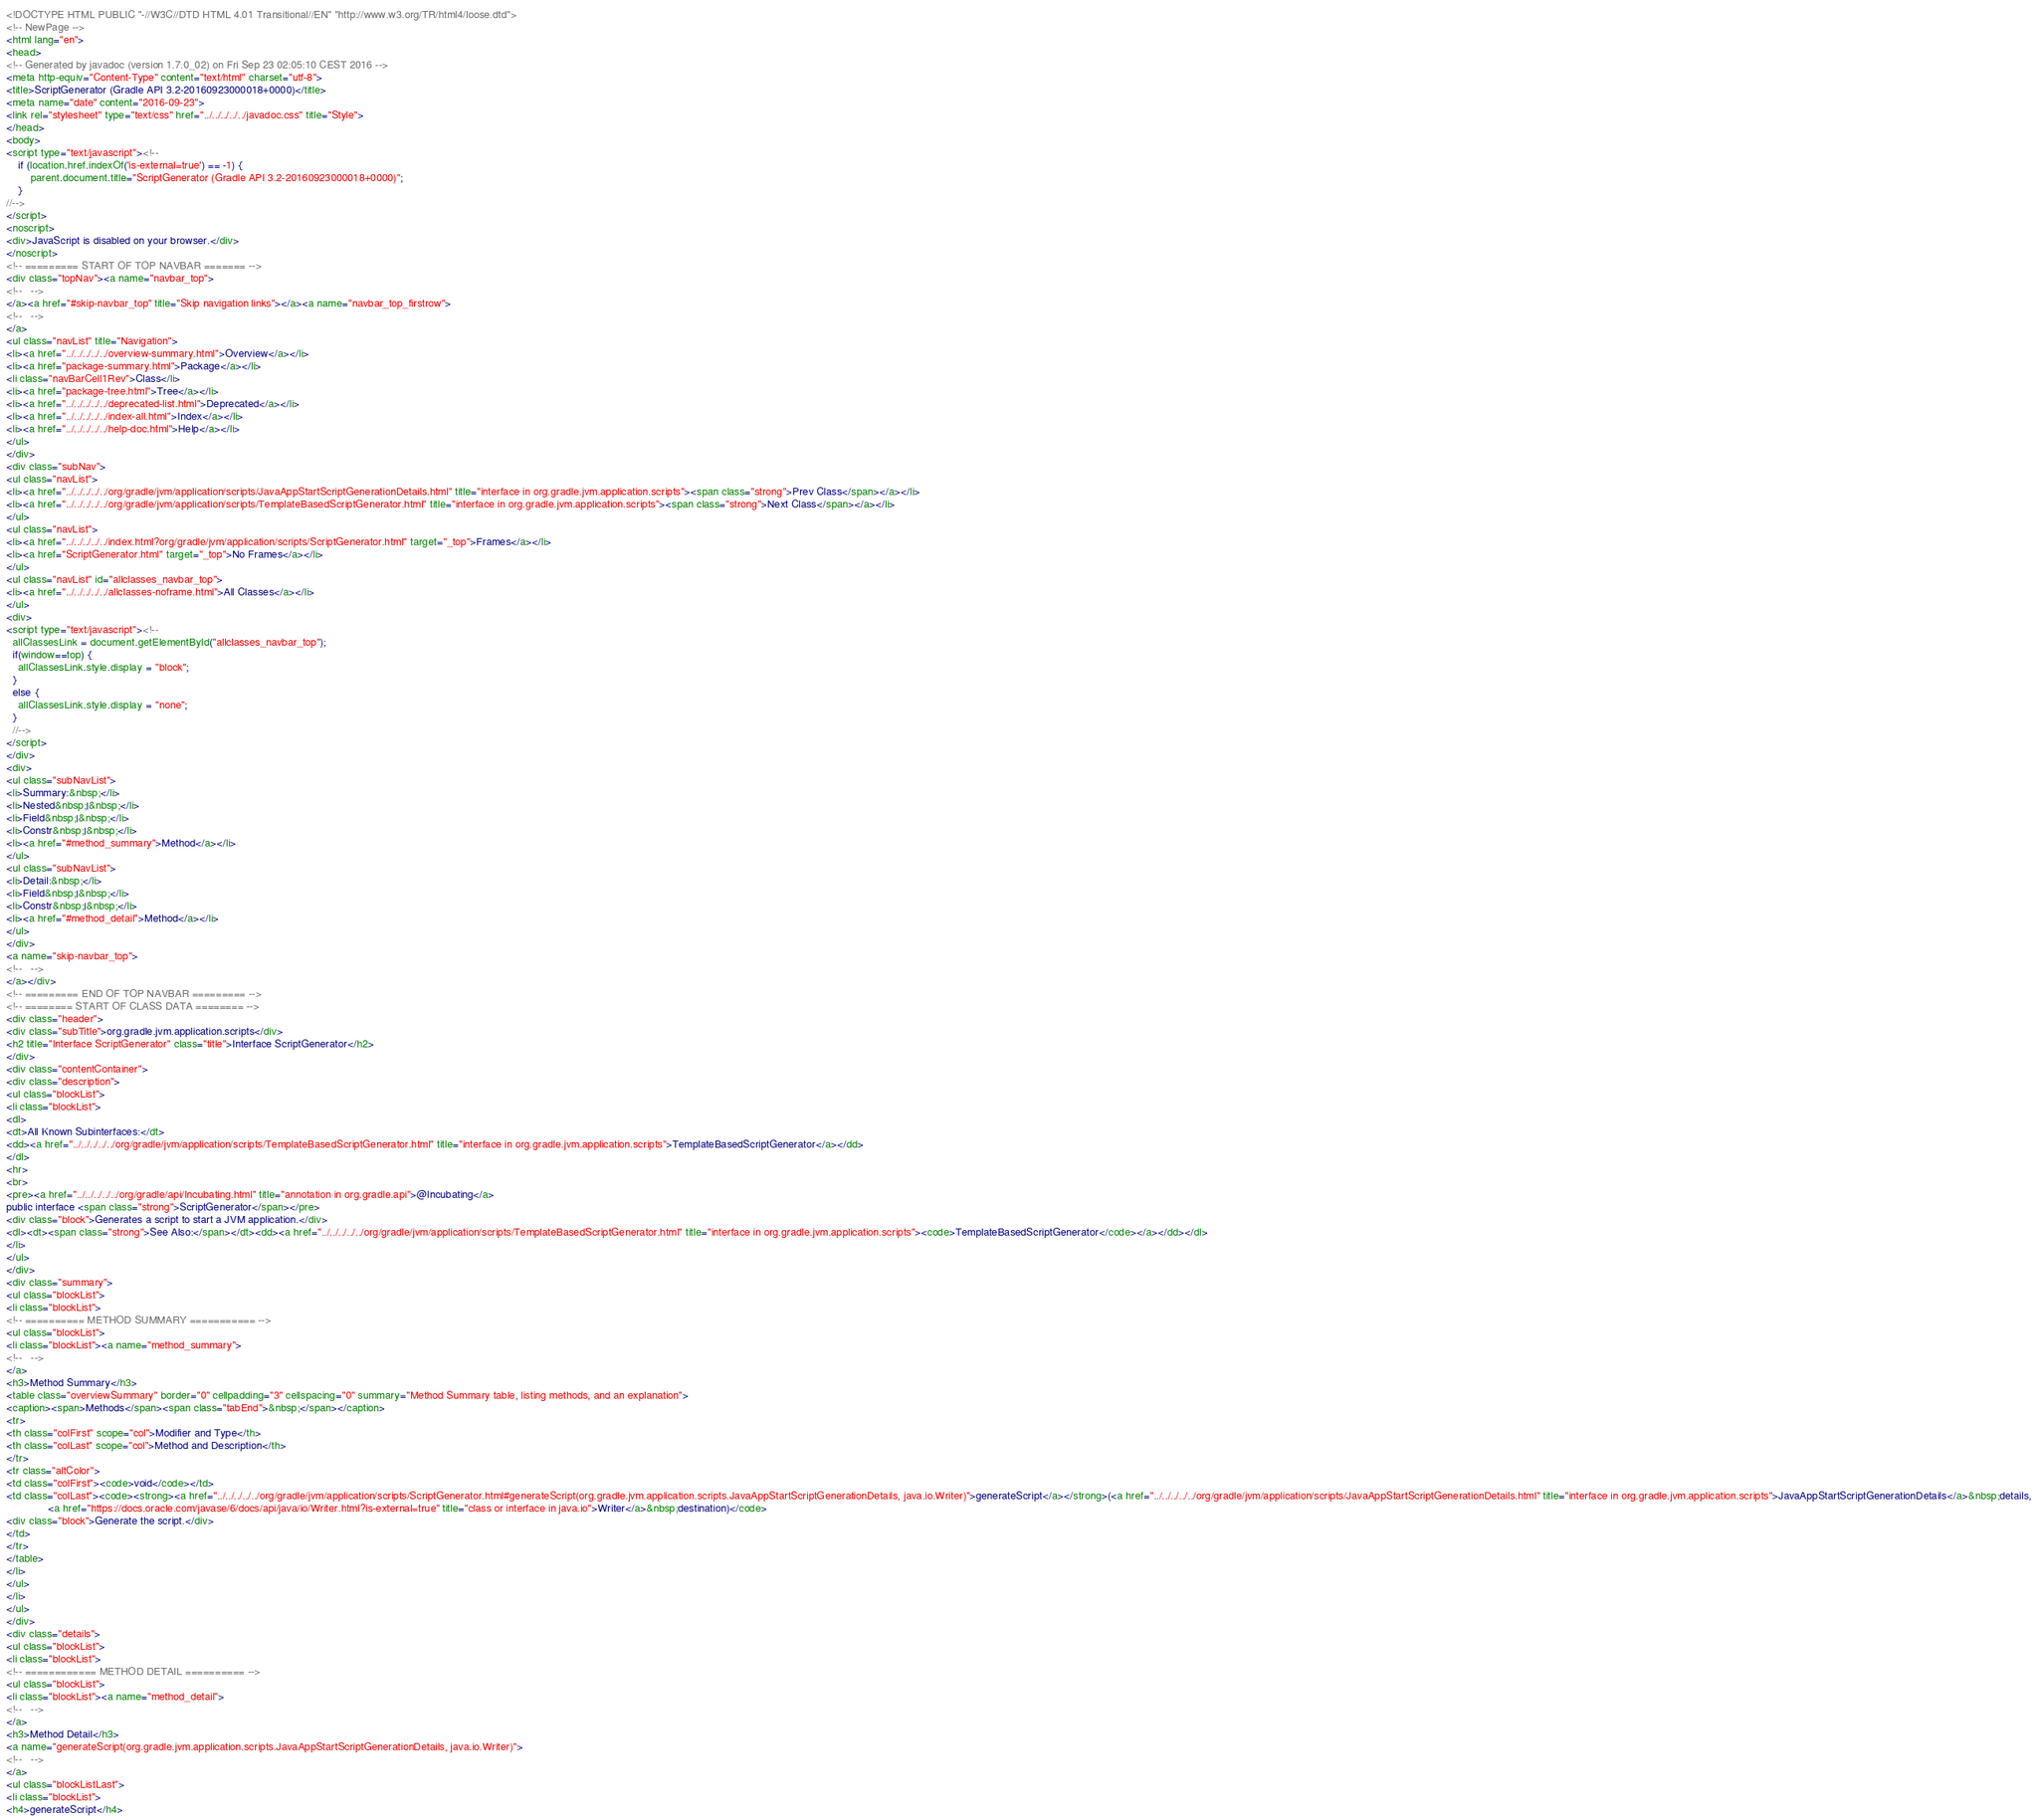<code> <loc_0><loc_0><loc_500><loc_500><_HTML_><!DOCTYPE HTML PUBLIC "-//W3C//DTD HTML 4.01 Transitional//EN" "http://www.w3.org/TR/html4/loose.dtd">
<!-- NewPage -->
<html lang="en">
<head>
<!-- Generated by javadoc (version 1.7.0_02) on Fri Sep 23 02:05:10 CEST 2016 -->
<meta http-equiv="Content-Type" content="text/html" charset="utf-8">
<title>ScriptGenerator (Gradle API 3.2-20160923000018+0000)</title>
<meta name="date" content="2016-09-23">
<link rel="stylesheet" type="text/css" href="../../../../../javadoc.css" title="Style">
</head>
<body>
<script type="text/javascript"><!--
    if (location.href.indexOf('is-external=true') == -1) {
        parent.document.title="ScriptGenerator (Gradle API 3.2-20160923000018+0000)";
    }
//-->
</script>
<noscript>
<div>JavaScript is disabled on your browser.</div>
</noscript>
<!-- ========= START OF TOP NAVBAR ======= -->
<div class="topNav"><a name="navbar_top">
<!--   -->
</a><a href="#skip-navbar_top" title="Skip navigation links"></a><a name="navbar_top_firstrow">
<!--   -->
</a>
<ul class="navList" title="Navigation">
<li><a href="../../../../../overview-summary.html">Overview</a></li>
<li><a href="package-summary.html">Package</a></li>
<li class="navBarCell1Rev">Class</li>
<li><a href="package-tree.html">Tree</a></li>
<li><a href="../../../../../deprecated-list.html">Deprecated</a></li>
<li><a href="../../../../../index-all.html">Index</a></li>
<li><a href="../../../../../help-doc.html">Help</a></li>
</ul>
</div>
<div class="subNav">
<ul class="navList">
<li><a href="../../../../../org/gradle/jvm/application/scripts/JavaAppStartScriptGenerationDetails.html" title="interface in org.gradle.jvm.application.scripts"><span class="strong">Prev Class</span></a></li>
<li><a href="../../../../../org/gradle/jvm/application/scripts/TemplateBasedScriptGenerator.html" title="interface in org.gradle.jvm.application.scripts"><span class="strong">Next Class</span></a></li>
</ul>
<ul class="navList">
<li><a href="../../../../../index.html?org/gradle/jvm/application/scripts/ScriptGenerator.html" target="_top">Frames</a></li>
<li><a href="ScriptGenerator.html" target="_top">No Frames</a></li>
</ul>
<ul class="navList" id="allclasses_navbar_top">
<li><a href="../../../../../allclasses-noframe.html">All Classes</a></li>
</ul>
<div>
<script type="text/javascript"><!--
  allClassesLink = document.getElementById("allclasses_navbar_top");
  if(window==top) {
    allClassesLink.style.display = "block";
  }
  else {
    allClassesLink.style.display = "none";
  }
  //-->
</script>
</div>
<div>
<ul class="subNavList">
<li>Summary:&nbsp;</li>
<li>Nested&nbsp;|&nbsp;</li>
<li>Field&nbsp;|&nbsp;</li>
<li>Constr&nbsp;|&nbsp;</li>
<li><a href="#method_summary">Method</a></li>
</ul>
<ul class="subNavList">
<li>Detail:&nbsp;</li>
<li>Field&nbsp;|&nbsp;</li>
<li>Constr&nbsp;|&nbsp;</li>
<li><a href="#method_detail">Method</a></li>
</ul>
</div>
<a name="skip-navbar_top">
<!--   -->
</a></div>
<!-- ========= END OF TOP NAVBAR ========= -->
<!-- ======== START OF CLASS DATA ======== -->
<div class="header">
<div class="subTitle">org.gradle.jvm.application.scripts</div>
<h2 title="Interface ScriptGenerator" class="title">Interface ScriptGenerator</h2>
</div>
<div class="contentContainer">
<div class="description">
<ul class="blockList">
<li class="blockList">
<dl>
<dt>All Known Subinterfaces:</dt>
<dd><a href="../../../../../org/gradle/jvm/application/scripts/TemplateBasedScriptGenerator.html" title="interface in org.gradle.jvm.application.scripts">TemplateBasedScriptGenerator</a></dd>
</dl>
<hr>
<br>
<pre><a href="../../../../../org/gradle/api/Incubating.html" title="annotation in org.gradle.api">@Incubating</a>
public interface <span class="strong">ScriptGenerator</span></pre>
<div class="block">Generates a script to start a JVM application.</div>
<dl><dt><span class="strong">See Also:</span></dt><dd><a href="../../../../../org/gradle/jvm/application/scripts/TemplateBasedScriptGenerator.html" title="interface in org.gradle.jvm.application.scripts"><code>TemplateBasedScriptGenerator</code></a></dd></dl>
</li>
</ul>
</div>
<div class="summary">
<ul class="blockList">
<li class="blockList">
<!-- ========== METHOD SUMMARY =========== -->
<ul class="blockList">
<li class="blockList"><a name="method_summary">
<!--   -->
</a>
<h3>Method Summary</h3>
<table class="overviewSummary" border="0" cellpadding="3" cellspacing="0" summary="Method Summary table, listing methods, and an explanation">
<caption><span>Methods</span><span class="tabEnd">&nbsp;</span></caption>
<tr>
<th class="colFirst" scope="col">Modifier and Type</th>
<th class="colLast" scope="col">Method and Description</th>
</tr>
<tr class="altColor">
<td class="colFirst"><code>void</code></td>
<td class="colLast"><code><strong><a href="../../../../../org/gradle/jvm/application/scripts/ScriptGenerator.html#generateScript(org.gradle.jvm.application.scripts.JavaAppStartScriptGenerationDetails, java.io.Writer)">generateScript</a></strong>(<a href="../../../../../org/gradle/jvm/application/scripts/JavaAppStartScriptGenerationDetails.html" title="interface in org.gradle.jvm.application.scripts">JavaAppStartScriptGenerationDetails</a>&nbsp;details,
              <a href="https://docs.oracle.com/javase/6/docs/api/java/io/Writer.html?is-external=true" title="class or interface in java.io">Writer</a>&nbsp;destination)</code>
<div class="block">Generate the script.</div>
</td>
</tr>
</table>
</li>
</ul>
</li>
</ul>
</div>
<div class="details">
<ul class="blockList">
<li class="blockList">
<!-- ============ METHOD DETAIL ========== -->
<ul class="blockList">
<li class="blockList"><a name="method_detail">
<!--   -->
</a>
<h3>Method Detail</h3>
<a name="generateScript(org.gradle.jvm.application.scripts.JavaAppStartScriptGenerationDetails, java.io.Writer)">
<!--   -->
</a>
<ul class="blockListLast">
<li class="blockList">
<h4>generateScript</h4></code> 